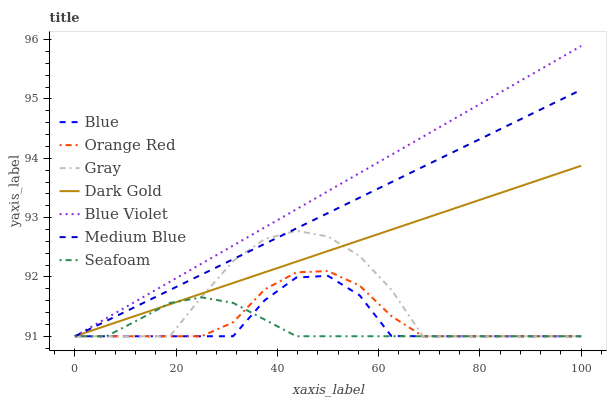Does Gray have the minimum area under the curve?
Answer yes or no. No. Does Gray have the maximum area under the curve?
Answer yes or no. No. Is Dark Gold the smoothest?
Answer yes or no. No. Is Dark Gold the roughest?
Answer yes or no. No. Does Gray have the highest value?
Answer yes or no. No. 